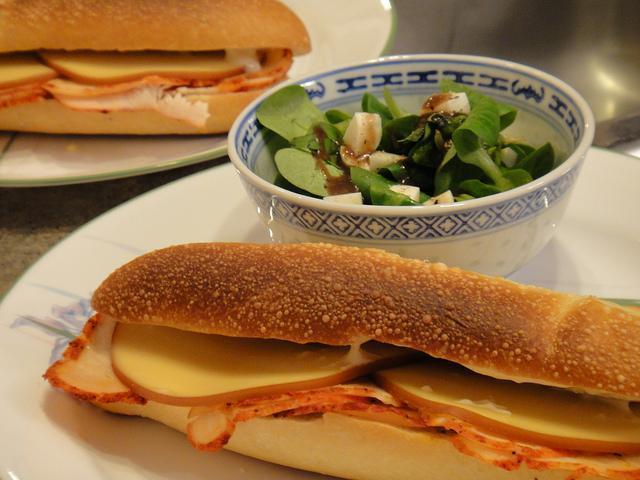How many sandwiches do you see?
Give a very brief answer. 2. How many dining tables can you see?
Give a very brief answer. 2. How many of the train cars can you see someone sticking their head out of?
Give a very brief answer. 0. 